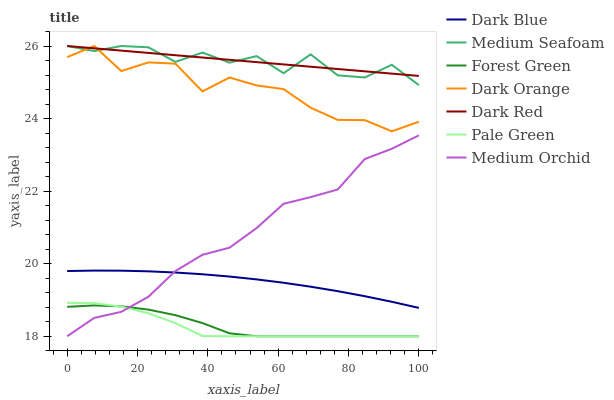Does Dark Red have the minimum area under the curve?
Answer yes or no. No. Does Dark Red have the maximum area under the curve?
Answer yes or no. No. Is Medium Orchid the smoothest?
Answer yes or no. No. Is Medium Orchid the roughest?
Answer yes or no. No. Does Dark Red have the lowest value?
Answer yes or no. No. Does Medium Orchid have the highest value?
Answer yes or no. No. Is Forest Green less than Medium Seafoam?
Answer yes or no. Yes. Is Dark Red greater than Dark Blue?
Answer yes or no. Yes. Does Forest Green intersect Medium Seafoam?
Answer yes or no. No. 